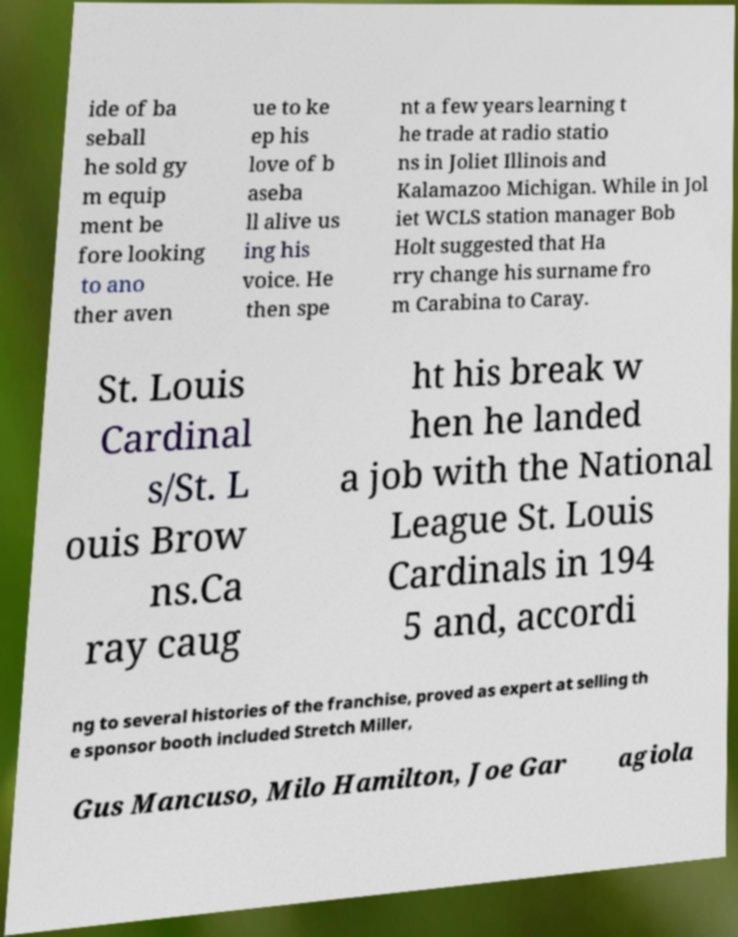Please read and relay the text visible in this image. What does it say? ide of ba seball he sold gy m equip ment be fore looking to ano ther aven ue to ke ep his love of b aseba ll alive us ing his voice. He then spe nt a few years learning t he trade at radio statio ns in Joliet Illinois and Kalamazoo Michigan. While in Jol iet WCLS station manager Bob Holt suggested that Ha rry change his surname fro m Carabina to Caray. St. Louis Cardinal s/St. L ouis Brow ns.Ca ray caug ht his break w hen he landed a job with the National League St. Louis Cardinals in 194 5 and, accordi ng to several histories of the franchise, proved as expert at selling th e sponsor booth included Stretch Miller, Gus Mancuso, Milo Hamilton, Joe Gar agiola 